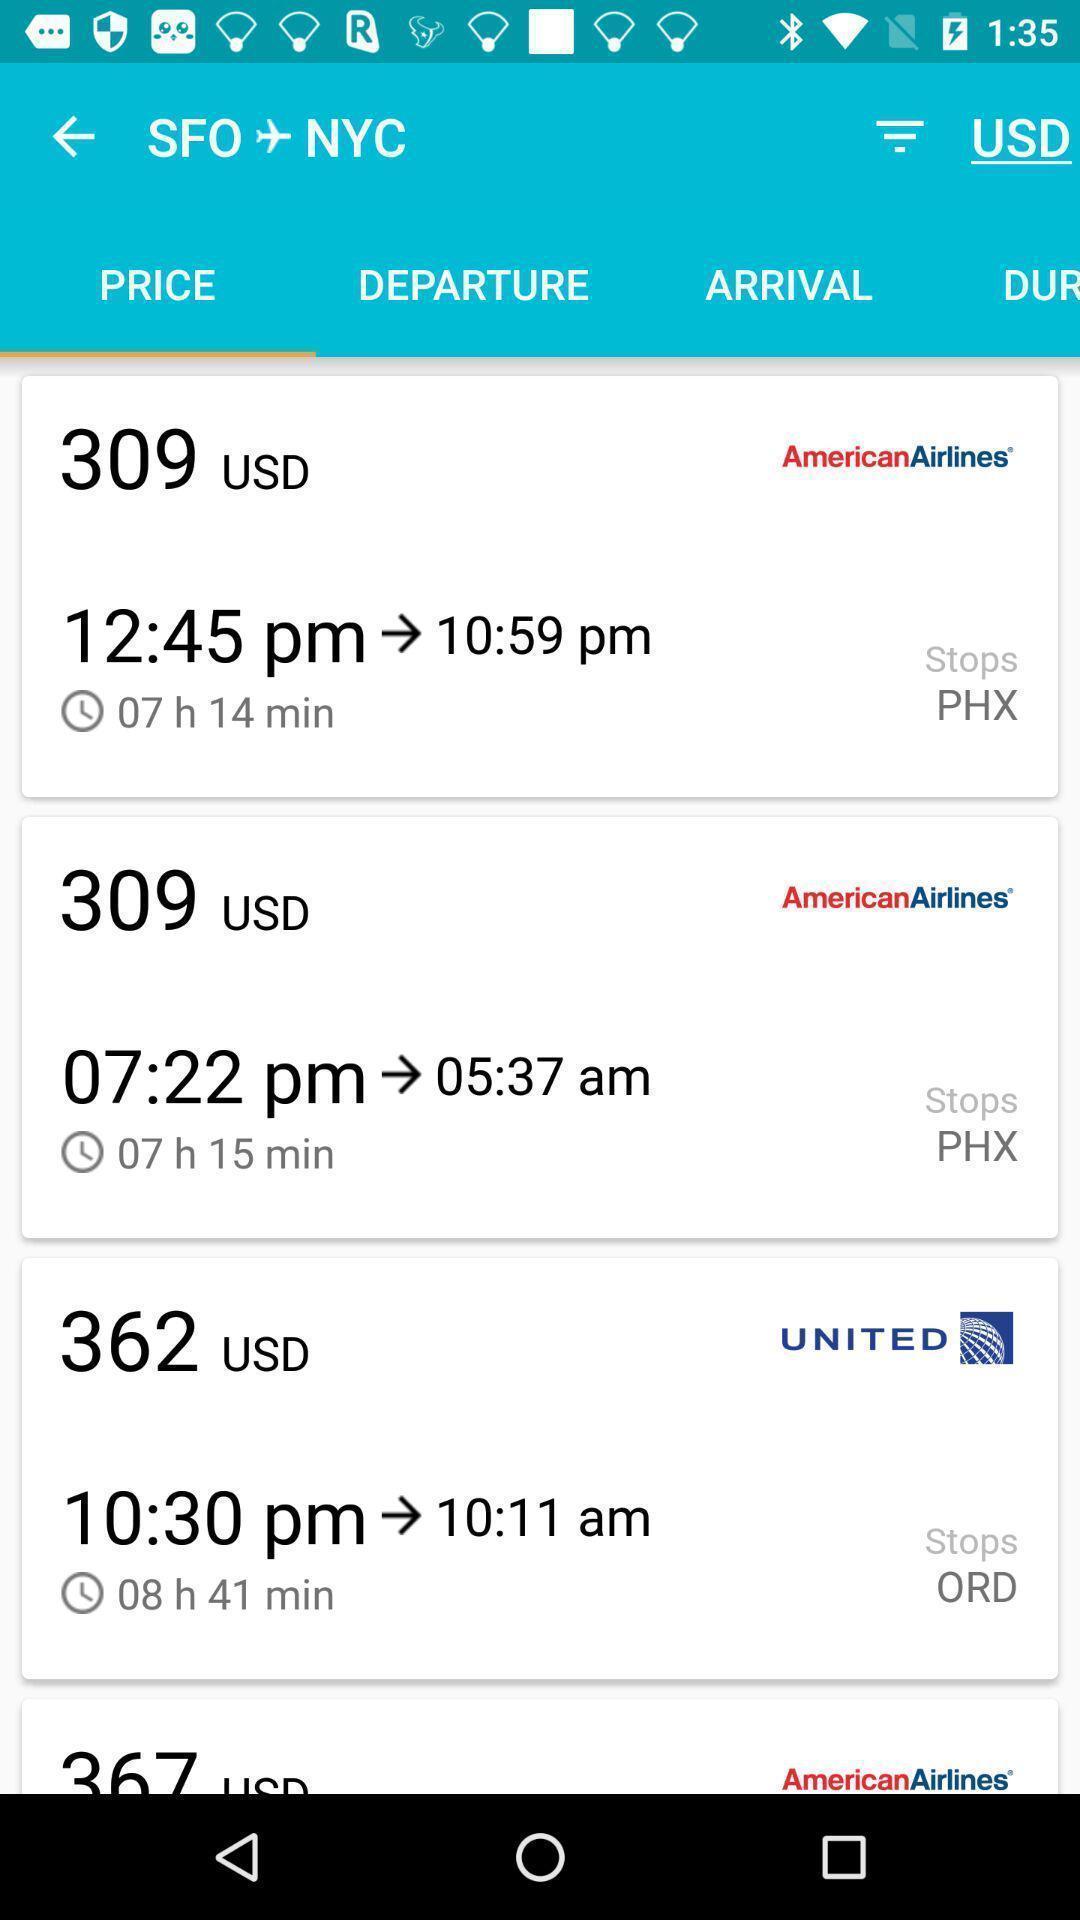What can you discern from this picture? Screen shows price page in travel application. 